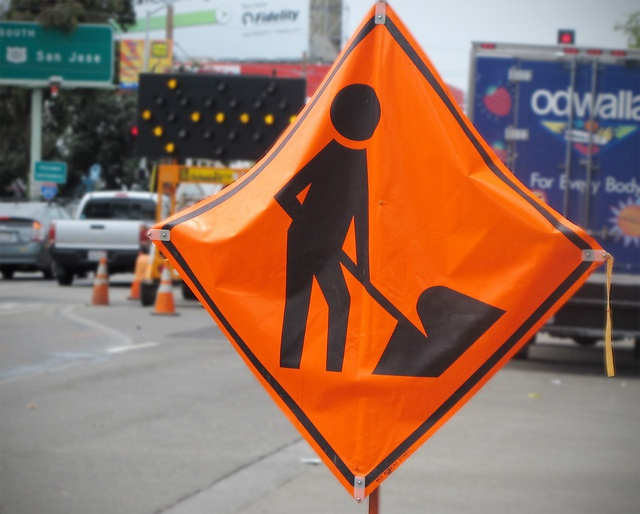Describe the objects in this image and their specific colors. I can see truck in gray, navy, darkblue, and darkgray tones, traffic light in gray, black, and maroon tones, truck in gray, black, darkgray, and lightgray tones, car in gray, darkgray, and black tones, and traffic light in gray, black, and teal tones in this image. 